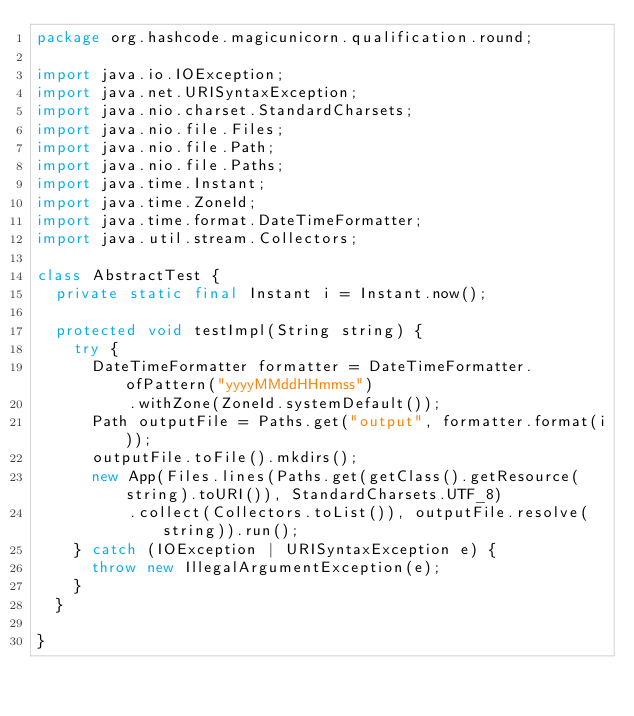Convert code to text. <code><loc_0><loc_0><loc_500><loc_500><_Java_>package org.hashcode.magicunicorn.qualification.round;

import java.io.IOException;
import java.net.URISyntaxException;
import java.nio.charset.StandardCharsets;
import java.nio.file.Files;
import java.nio.file.Path;
import java.nio.file.Paths;
import java.time.Instant;
import java.time.ZoneId;
import java.time.format.DateTimeFormatter;
import java.util.stream.Collectors;

class AbstractTest {
	private static final Instant i = Instant.now();

	protected void testImpl(String string) {
		try {
			DateTimeFormatter formatter = DateTimeFormatter.ofPattern("yyyyMMddHHmmss")
					.withZone(ZoneId.systemDefault());
			Path outputFile = Paths.get("output", formatter.format(i));
			outputFile.toFile().mkdirs();
			new App(Files.lines(Paths.get(getClass().getResource(string).toURI()), StandardCharsets.UTF_8)
					.collect(Collectors.toList()), outputFile.resolve(string)).run();
		} catch (IOException | URISyntaxException e) {
			throw new IllegalArgumentException(e);
		}
	}

}
</code> 